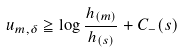Convert formula to latex. <formula><loc_0><loc_0><loc_500><loc_500>u _ { m , \delta } \geqq \log \frac { h _ { ( m ) } } { h _ { ( s ) } } + C _ { - } ( s )</formula> 